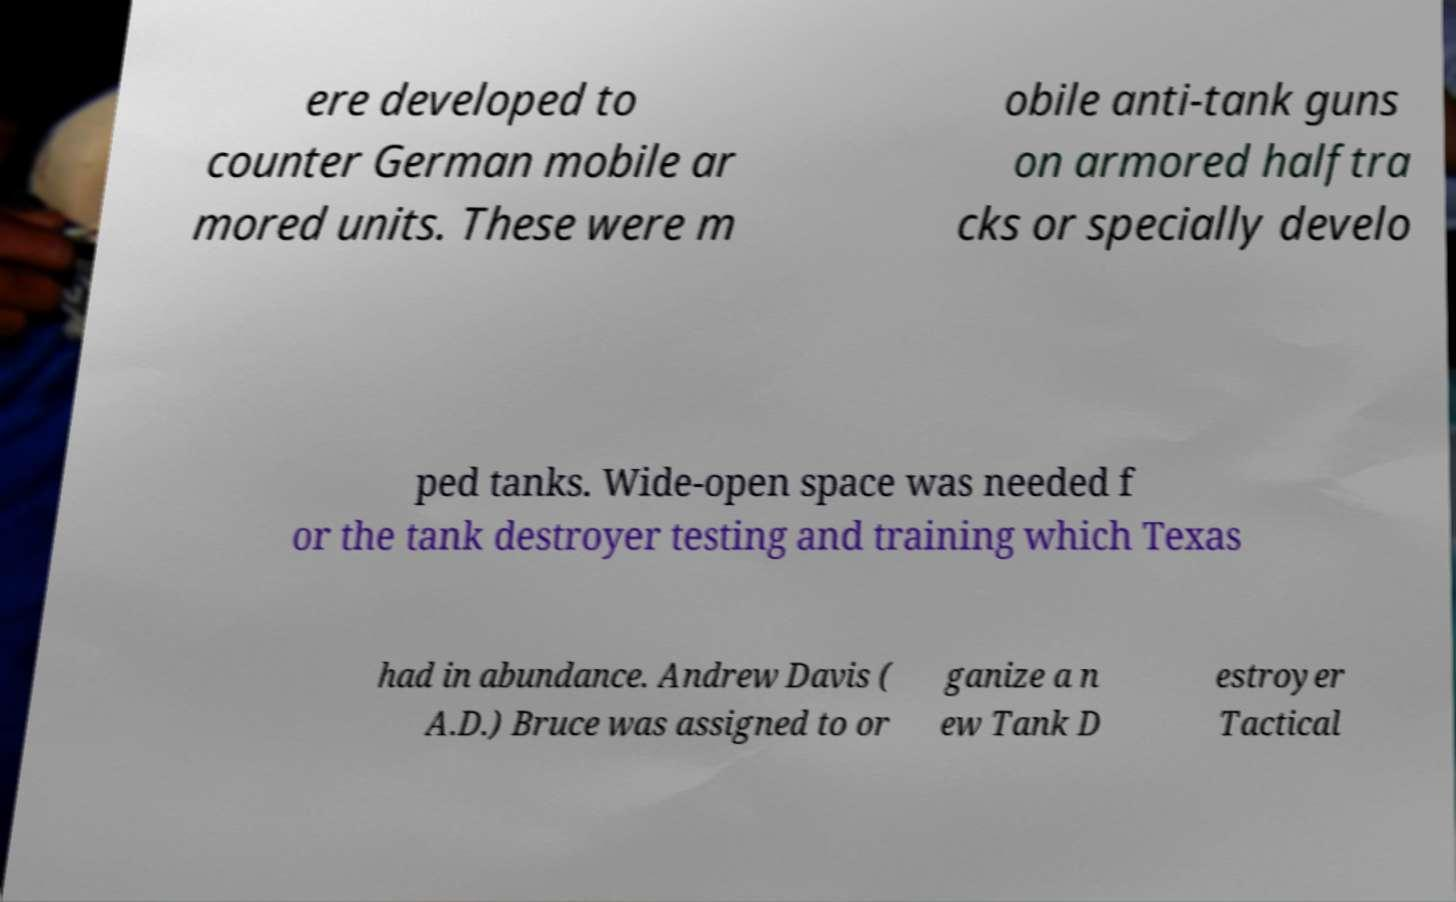For documentation purposes, I need the text within this image transcribed. Could you provide that? ere developed to counter German mobile ar mored units. These were m obile anti-tank guns on armored halftra cks or specially develo ped tanks. Wide-open space was needed f or the tank destroyer testing and training which Texas had in abundance. Andrew Davis ( A.D.) Bruce was assigned to or ganize a n ew Tank D estroyer Tactical 